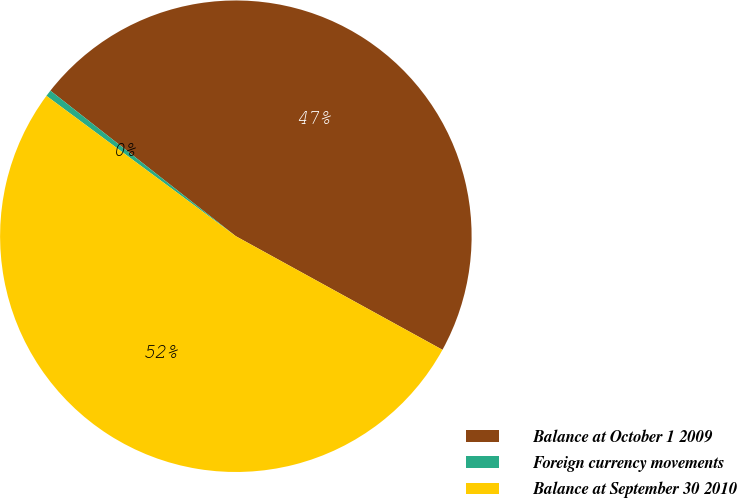<chart> <loc_0><loc_0><loc_500><loc_500><pie_chart><fcel>Balance at October 1 2009<fcel>Foreign currency movements<fcel>Balance at September 30 2010<nl><fcel>47.41%<fcel>0.44%<fcel>52.15%<nl></chart> 